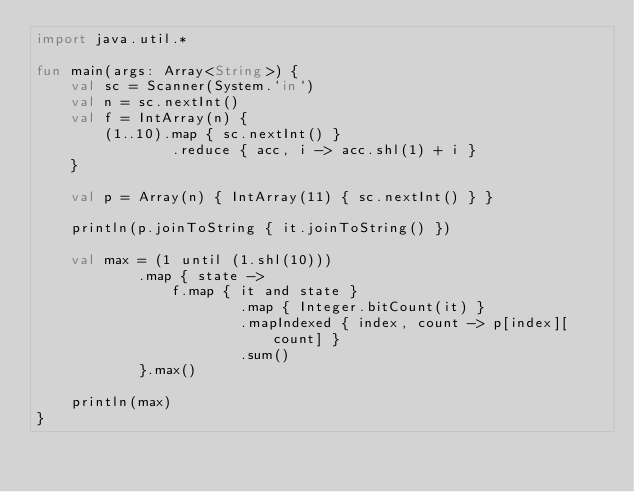<code> <loc_0><loc_0><loc_500><loc_500><_Kotlin_>import java.util.*

fun main(args: Array<String>) {
    val sc = Scanner(System.`in`)
    val n = sc.nextInt()
    val f = IntArray(n) {
        (1..10).map { sc.nextInt() }
                .reduce { acc, i -> acc.shl(1) + i }
    }

    val p = Array(n) { IntArray(11) { sc.nextInt() } }

    println(p.joinToString { it.joinToString() })

    val max = (1 until (1.shl(10)))
            .map { state ->
                f.map { it and state }
                        .map { Integer.bitCount(it) }
                        .mapIndexed { index, count -> p[index][count] }
                        .sum()
            }.max()

    println(max)
}</code> 